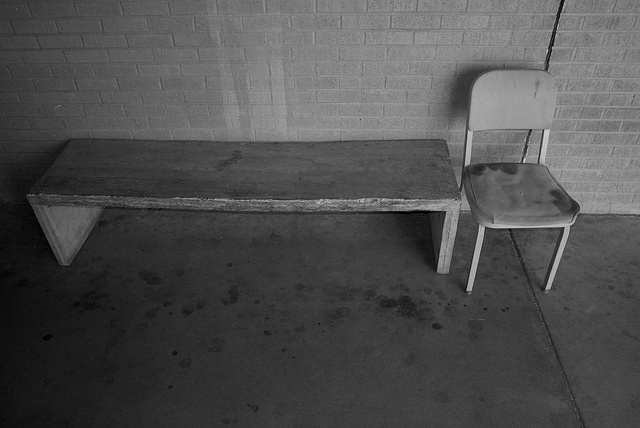Describe the objects in this image and their specific colors. I can see bench in black, gray, and lightgray tones and chair in black, gray, darkgray, and lightgray tones in this image. 